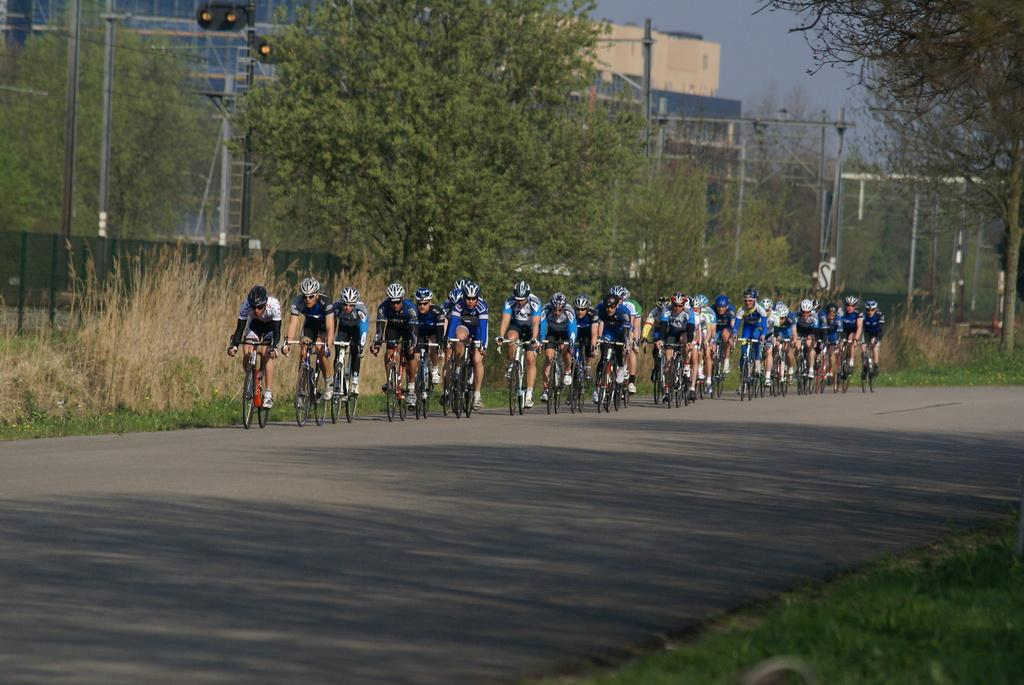What are the people in the image doing? The people in the image are riding bicycles. What can be seen in the background of the image? There are poles, trees with green color, and buildings in the background of the image. What is the color of the sky in the image? The sky is blue in color. What type of locket is hanging from the bicycle in the image? There is no locket present in the image; it features a group of people riding bicycles in a setting with poles, trees, buildings, and a blue sky. 